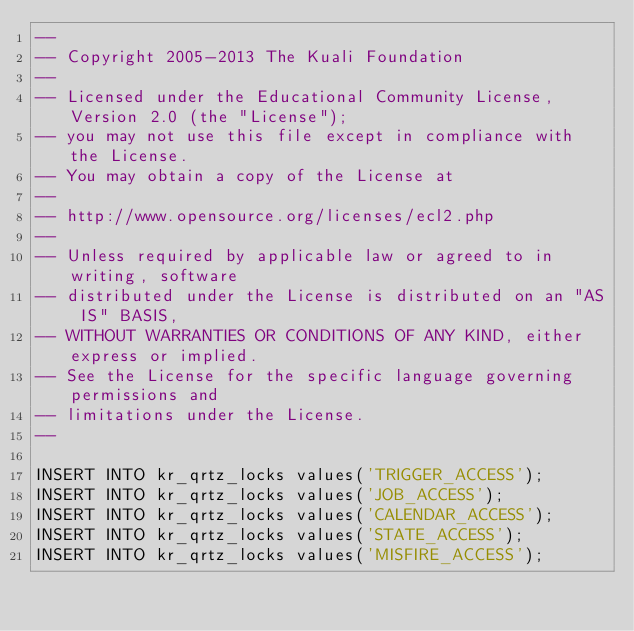<code> <loc_0><loc_0><loc_500><loc_500><_SQL_>--
-- Copyright 2005-2013 The Kuali Foundation
--
-- Licensed under the Educational Community License, Version 2.0 (the "License");
-- you may not use this file except in compliance with the License.
-- You may obtain a copy of the License at
--
-- http://www.opensource.org/licenses/ecl2.php
--
-- Unless required by applicable law or agreed to in writing, software
-- distributed under the License is distributed on an "AS IS" BASIS,
-- WITHOUT WARRANTIES OR CONDITIONS OF ANY KIND, either express or implied.
-- See the License for the specific language governing permissions and
-- limitations under the License.
--

INSERT INTO kr_qrtz_locks values('TRIGGER_ACCESS');
INSERT INTO kr_qrtz_locks values('JOB_ACCESS');
INSERT INTO kr_qrtz_locks values('CALENDAR_ACCESS');
INSERT INTO kr_qrtz_locks values('STATE_ACCESS');
INSERT INTO kr_qrtz_locks values('MISFIRE_ACCESS');
</code> 